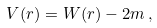<formula> <loc_0><loc_0><loc_500><loc_500>V ( r ) = W ( r ) - 2 m \, ,</formula> 